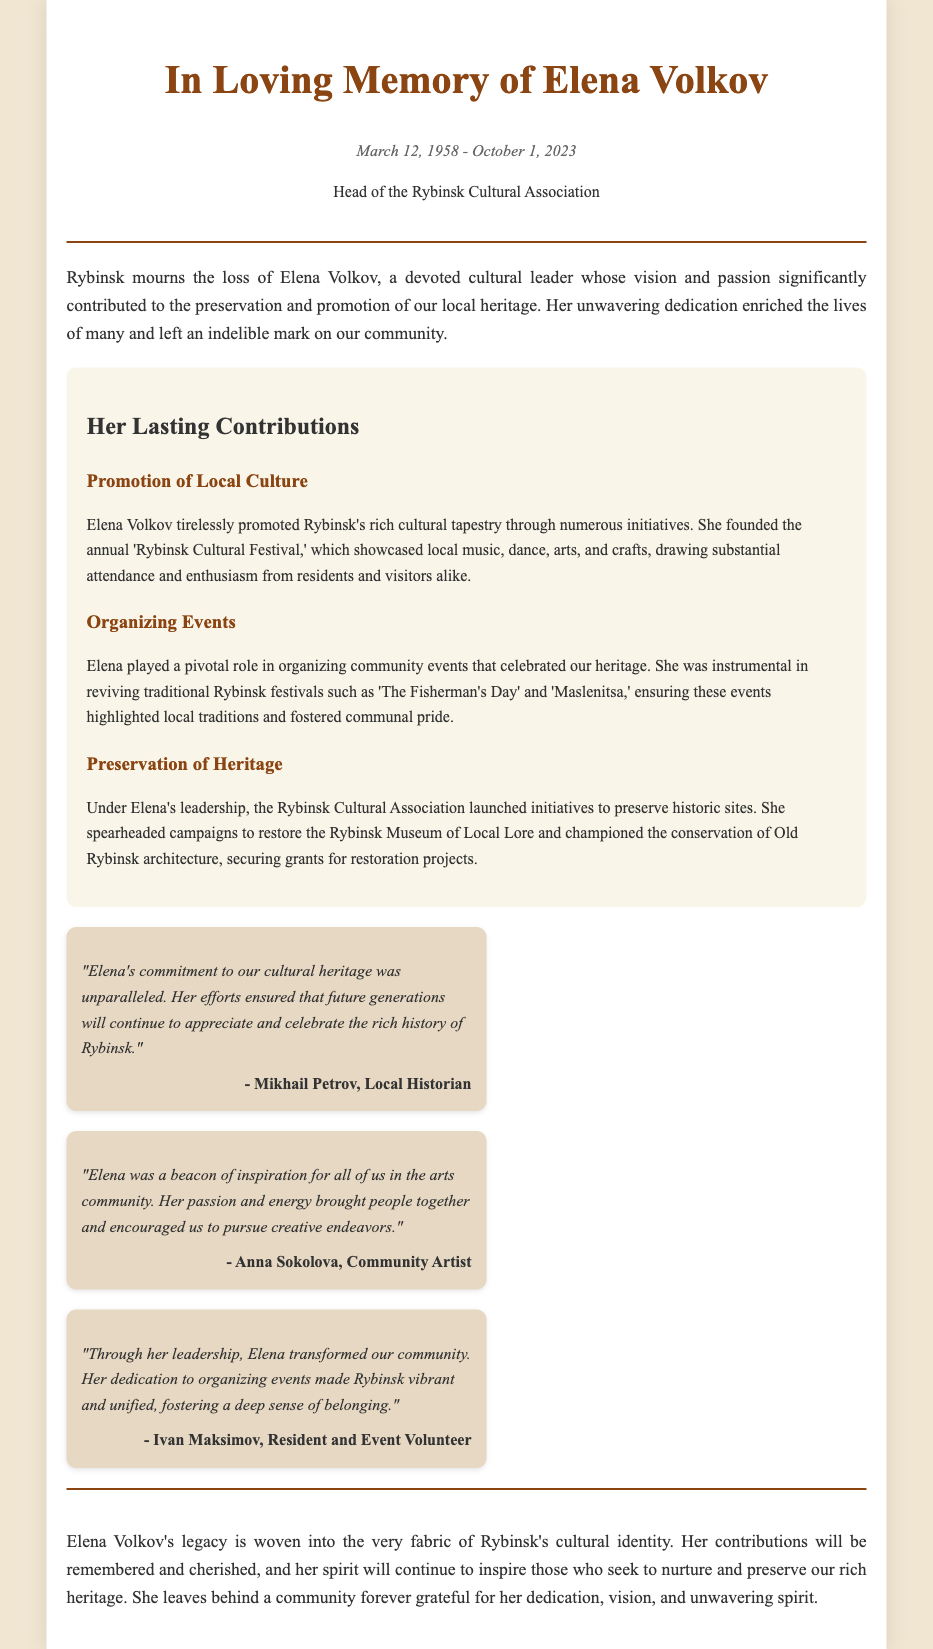What was Elena Volkov's role? Elena Volkov was the Head of the Rybinsk Cultural Association, as stated in the document.
Answer: Head of the Rybinsk Cultural Association What date did Elena Volkov pass away? The document provides the date of Elena Volkov's passing as October 1, 2023.
Answer: October 1, 2023 How many events did Elena help organize? The document discusses several events organized by Elena, mentioning specific festivals, thus indicating multiple events were organized.
Answer: Multiple events Which festival did Elena found? The document specifies that she founded the annual 'Rybinsk Cultural Festival.'
Answer: Rybinsk Cultural Festival Who described Elena as a beacon of inspiration? The document attributes this description to Anna Sokolova, a community artist.
Answer: Anna Sokolova What heritage preservation initiative did Elena launch? The document states that she launched initiatives to preserve historic sites as part of her efforts.
Answer: Preserving historic sites What was Elena's commitment towards cultural heritage? According to Mikhail Petrov, her commitment to cultural heritage was described as unparalleled in the document.
Answer: Unparalleled What did Ivan Maksimov say about Elena's impact on the community? Ivan Maksimov stated that Elena transformed the community, fostering a sense of belonging.
Answer: Transformed the community Why is this document categorized as an obituary? The document commemorates the life and contributions of Elena Volkov following her death, which is characteristic of an obituary.
Answer: Commemorates the life and contributions 